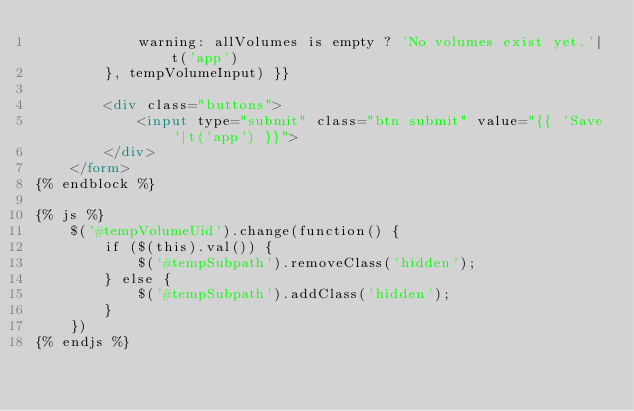Convert code to text. <code><loc_0><loc_0><loc_500><loc_500><_HTML_>            warning: allVolumes is empty ? 'No volumes exist yet.'|t('app')
        }, tempVolumeInput) }}

        <div class="buttons">
            <input type="submit" class="btn submit" value="{{ 'Save'|t('app') }}">
        </div>
    </form>
{% endblock %}

{% js %}
    $('#tempVolumeUid').change(function() {
        if ($(this).val()) {
            $('#tempSubpath').removeClass('hidden');
        } else {
            $('#tempSubpath').addClass('hidden');
        }
    })
{% endjs %}
</code> 